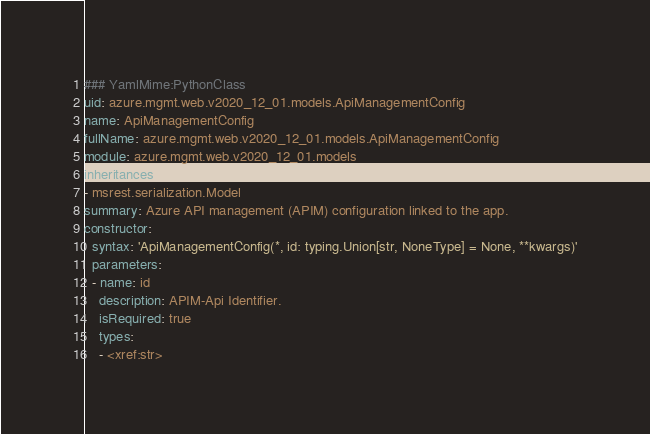<code> <loc_0><loc_0><loc_500><loc_500><_YAML_>### YamlMime:PythonClass
uid: azure.mgmt.web.v2020_12_01.models.ApiManagementConfig
name: ApiManagementConfig
fullName: azure.mgmt.web.v2020_12_01.models.ApiManagementConfig
module: azure.mgmt.web.v2020_12_01.models
inheritances:
- msrest.serialization.Model
summary: Azure API management (APIM) configuration linked to the app.
constructor:
  syntax: 'ApiManagementConfig(*, id: typing.Union[str, NoneType] = None, **kwargs)'
  parameters:
  - name: id
    description: APIM-Api Identifier.
    isRequired: true
    types:
    - <xref:str>
</code> 